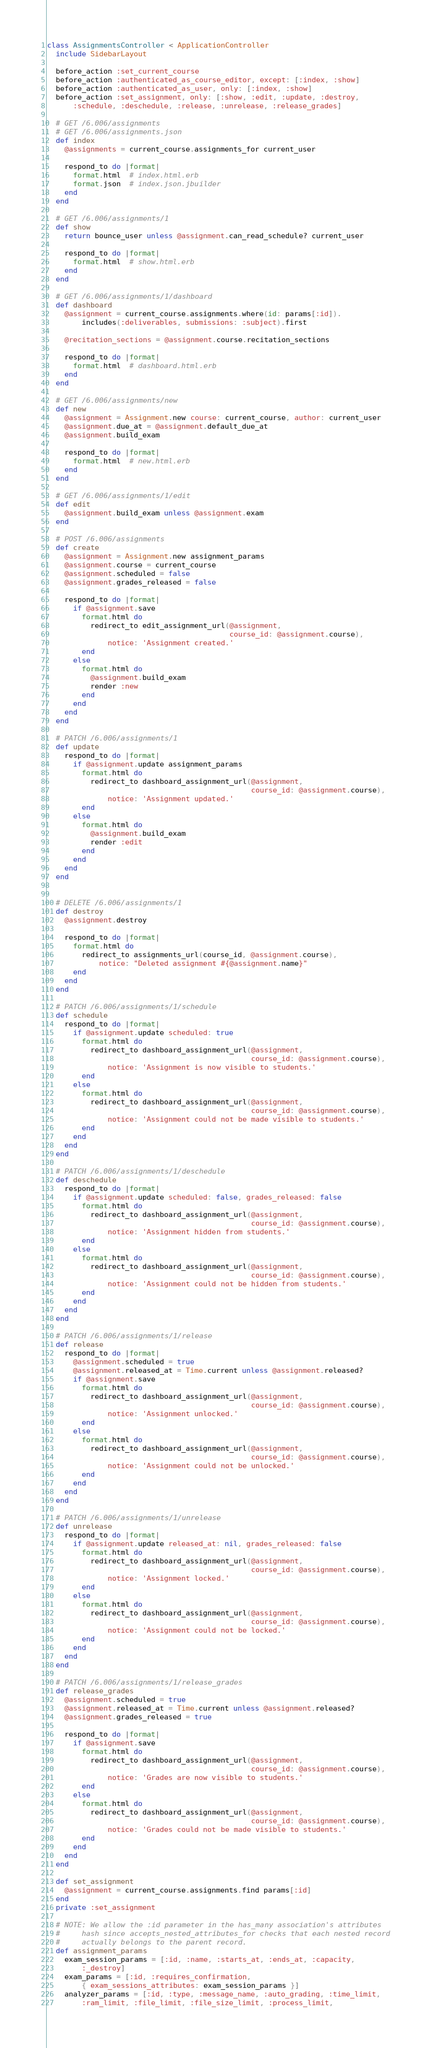Convert code to text. <code><loc_0><loc_0><loc_500><loc_500><_Ruby_>class AssignmentsController < ApplicationController
  include SidebarLayout

  before_action :set_current_course
  before_action :authenticated_as_course_editor, except: [:index, :show]
  before_action :authenticated_as_user, only: [:index, :show]
  before_action :set_assignment, only: [:show, :edit, :update, :destroy,
      :schedule, :deschedule, :release, :unrelease, :release_grades]

  # GET /6.006/assignments
  # GET /6.006/assignments.json
  def index
    @assignments = current_course.assignments_for current_user

    respond_to do |format|
      format.html  # index.html.erb
      format.json  # index.json.jbuilder
    end
  end

  # GET /6.006/assignments/1
  def show
    return bounce_user unless @assignment.can_read_schedule? current_user

    respond_to do |format|
      format.html  # show.html.erb
    end
  end

  # GET /6.006/assignments/1/dashboard
  def dashboard
    @assignment = current_course.assignments.where(id: params[:id]).
        includes(:deliverables, submissions: :subject).first

    @recitation_sections = @assignment.course.recitation_sections

    respond_to do |format|
      format.html  # dashboard.html.erb
    end
  end

  # GET /6.006/assignments/new
  def new
    @assignment = Assignment.new course: current_course, author: current_user
    @assignment.due_at = @assignment.default_due_at
    @assignment.build_exam

    respond_to do |format|
      format.html  # new.html.erb
    end
  end

  # GET /6.006/assignments/1/edit
  def edit
    @assignment.build_exam unless @assignment.exam
  end

  # POST /6.006/assignments
  def create
    @assignment = Assignment.new assignment_params
    @assignment.course = current_course
    @assignment.scheduled = false
    @assignment.grades_released = false

    respond_to do |format|
      if @assignment.save
        format.html do
          redirect_to edit_assignment_url(@assignment,
                                          course_id: @assignment.course),
              notice: 'Assignment created.'
        end
      else
        format.html do
          @assignment.build_exam
          render :new
        end
      end
    end
  end

  # PATCH /6.006/assignments/1
  def update
    respond_to do |format|
      if @assignment.update assignment_params
        format.html do
          redirect_to dashboard_assignment_url(@assignment,
                                               course_id: @assignment.course),
              notice: 'Assignment updated.'
        end
      else
        format.html do
          @assignment.build_exam
          render :edit
        end
      end
    end
  end


  # DELETE /6.006/assignments/1
  def destroy
    @assignment.destroy

    respond_to do |format|
      format.html do
        redirect_to assignments_url(course_id, @assignment.course),
            notice: "Deleted assignment #{@assignment.name}"
      end
    end
  end

  # PATCH /6.006/assignments/1/schedule
  def schedule
    respond_to do |format|
      if @assignment.update scheduled: true
        format.html do
          redirect_to dashboard_assignment_url(@assignment,
                                               course_id: @assignment.course),
              notice: 'Assignment is now visible to students.'
        end
      else
        format.html do
          redirect_to dashboard_assignment_url(@assignment,
                                               course_id: @assignment.course),
              notice: 'Assignment could not be made visible to students.'
        end
      end
    end
  end

  # PATCH /6.006/assignments/1/deschedule
  def deschedule
    respond_to do |format|
      if @assignment.update scheduled: false, grades_released: false
        format.html do
          redirect_to dashboard_assignment_url(@assignment,
                                               course_id: @assignment.course),
              notice: 'Assignment hidden from students.'
        end
      else
        format.html do
          redirect_to dashboard_assignment_url(@assignment,
                                               course_id: @assignment.course),
              notice: 'Assignment could not be hidden from students.'
        end
      end
    end
  end

  # PATCH /6.006/assignments/1/release
  def release
    respond_to do |format|
      @assignment.scheduled = true
      @assignment.released_at = Time.current unless @assignment.released?
      if @assignment.save
        format.html do
          redirect_to dashboard_assignment_url(@assignment,
                                               course_id: @assignment.course),
              notice: 'Assignment unlocked.'
        end
      else
        format.html do
          redirect_to dashboard_assignment_url(@assignment,
                                               course_id: @assignment.course),
              notice: 'Assignment could not be unlocked.'
        end
      end
    end
  end

  # PATCH /6.006/assignments/1/unrelease
  def unrelease
    respond_to do |format|
      if @assignment.update released_at: nil, grades_released: false
        format.html do
          redirect_to dashboard_assignment_url(@assignment,
                                               course_id: @assignment.course),
              notice: 'Assignment locked.'
        end
      else
        format.html do
          redirect_to dashboard_assignment_url(@assignment,
                                               course_id: @assignment.course),
              notice: 'Assignment could not be locked.'
        end
      end
    end
  end

  # PATCH /6.006/assignments/1/release_grades
  def release_grades
    @assignment.scheduled = true
    @assignment.released_at = Time.current unless @assignment.released?
    @assignment.grades_released = true

    respond_to do |format|
      if @assignment.save
        format.html do
          redirect_to dashboard_assignment_url(@assignment,
                                               course_id: @assignment.course),
              notice: 'Grades are now visible to students.'
        end
      else
        format.html do
          redirect_to dashboard_assignment_url(@assignment,
                                               course_id: @assignment.course),
              notice: 'Grades could not be made visible to students.'
        end
      end
    end
  end

  def set_assignment
    @assignment = current_course.assignments.find params[:id]
  end
  private :set_assignment

  # NOTE: We allow the :id parameter in the has_many association's attributes
  #     hash since accepts_nested_attributes_for checks that each nested record
  #     actually belongs to the parent record.
  def assignment_params
    exam_session_params = [:id, :name, :starts_at, :ends_at, :capacity,
        :_destroy]
    exam_params = [:id, :requires_confirmation,
        { exam_sessions_attributes: exam_session_params }]
    analyzer_params = [:id, :type, :message_name, :auto_grading, :time_limit,
        :ram_limit, :file_limit, :file_size_limit, :process_limit,</code> 